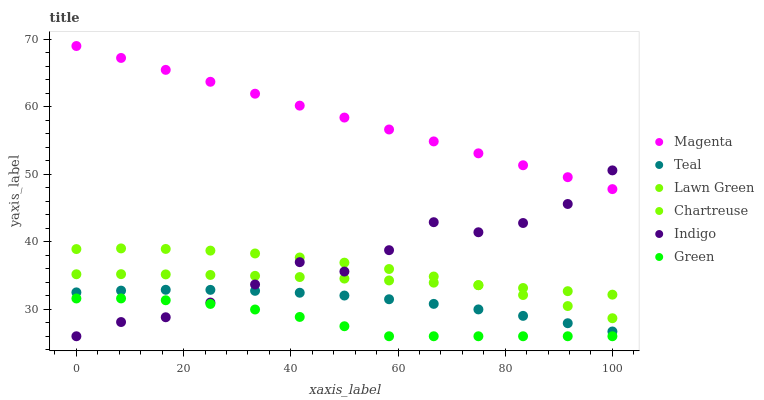Does Green have the minimum area under the curve?
Answer yes or no. Yes. Does Magenta have the maximum area under the curve?
Answer yes or no. Yes. Does Indigo have the minimum area under the curve?
Answer yes or no. No. Does Indigo have the maximum area under the curve?
Answer yes or no. No. Is Magenta the smoothest?
Answer yes or no. Yes. Is Indigo the roughest?
Answer yes or no. Yes. Is Chartreuse the smoothest?
Answer yes or no. No. Is Chartreuse the roughest?
Answer yes or no. No. Does Indigo have the lowest value?
Answer yes or no. Yes. Does Chartreuse have the lowest value?
Answer yes or no. No. Does Magenta have the highest value?
Answer yes or no. Yes. Does Indigo have the highest value?
Answer yes or no. No. Is Green less than Chartreuse?
Answer yes or no. Yes. Is Lawn Green greater than Green?
Answer yes or no. Yes. Does Indigo intersect Green?
Answer yes or no. Yes. Is Indigo less than Green?
Answer yes or no. No. Is Indigo greater than Green?
Answer yes or no. No. Does Green intersect Chartreuse?
Answer yes or no. No. 